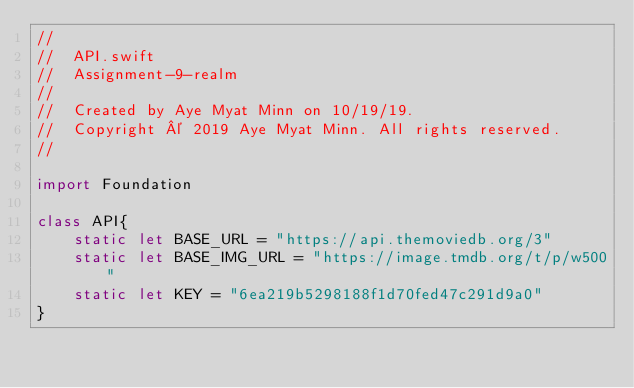Convert code to text. <code><loc_0><loc_0><loc_500><loc_500><_Swift_>//
//  API.swift
//  Assignment-9-realm
//
//  Created by Aye Myat Minn on 10/19/19.
//  Copyright © 2019 Aye Myat Minn. All rights reserved.
//

import Foundation

class API{
    static let BASE_URL = "https://api.themoviedb.org/3"
    static let BASE_IMG_URL = "https://image.tmdb.org/t/p/w500"
    static let KEY = "6ea219b5298188f1d70fed47c291d9a0"
}
</code> 